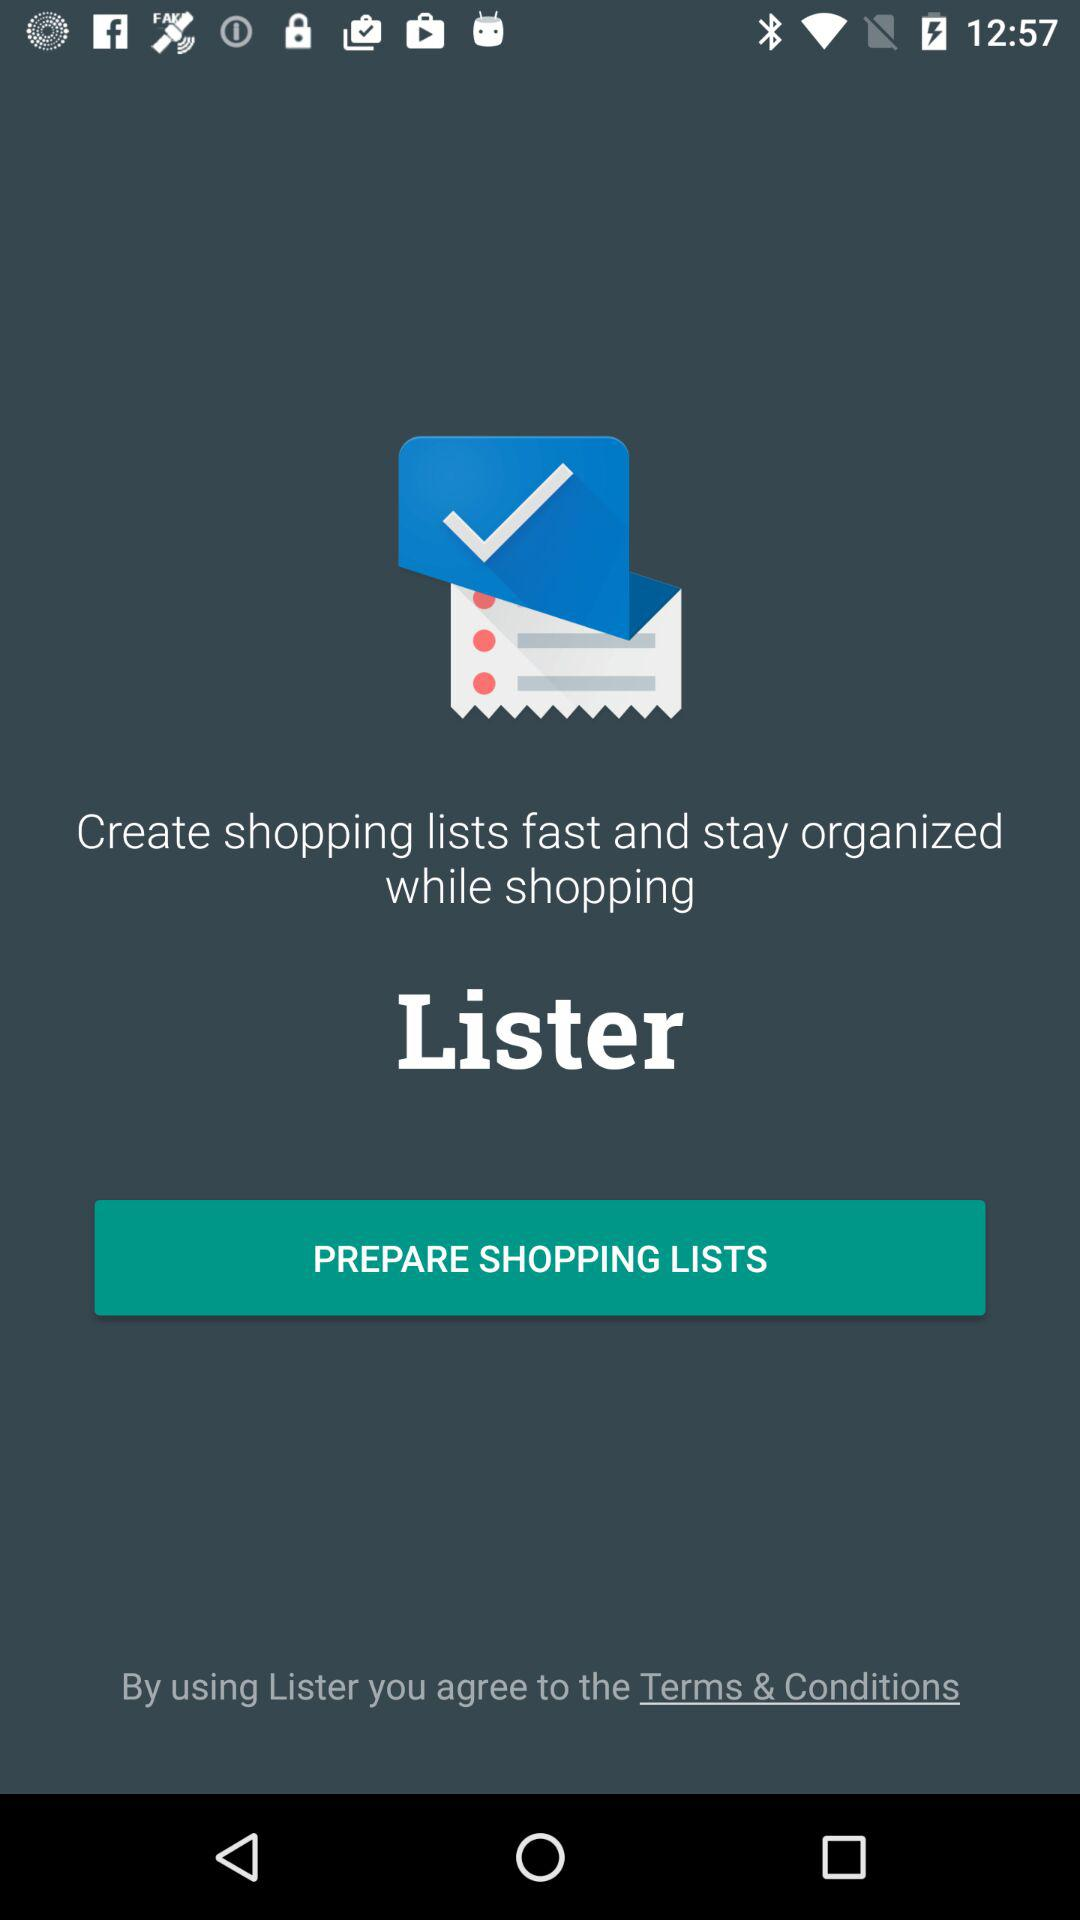What's the application name? The application name is "Shopping list — Lister". 